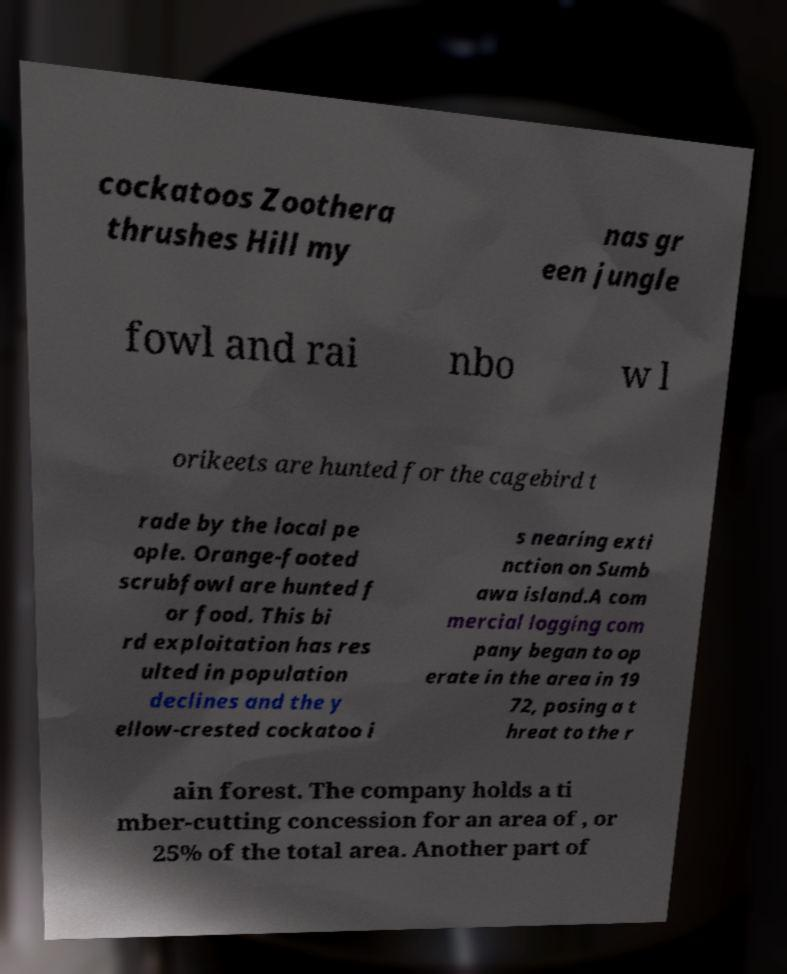Please read and relay the text visible in this image. What does it say? cockatoos Zoothera thrushes Hill my nas gr een jungle fowl and rai nbo w l orikeets are hunted for the cagebird t rade by the local pe ople. Orange-footed scrubfowl are hunted f or food. This bi rd exploitation has res ulted in population declines and the y ellow-crested cockatoo i s nearing exti nction on Sumb awa island.A com mercial logging com pany began to op erate in the area in 19 72, posing a t hreat to the r ain forest. The company holds a ti mber-cutting concession for an area of , or 25% of the total area. Another part of 